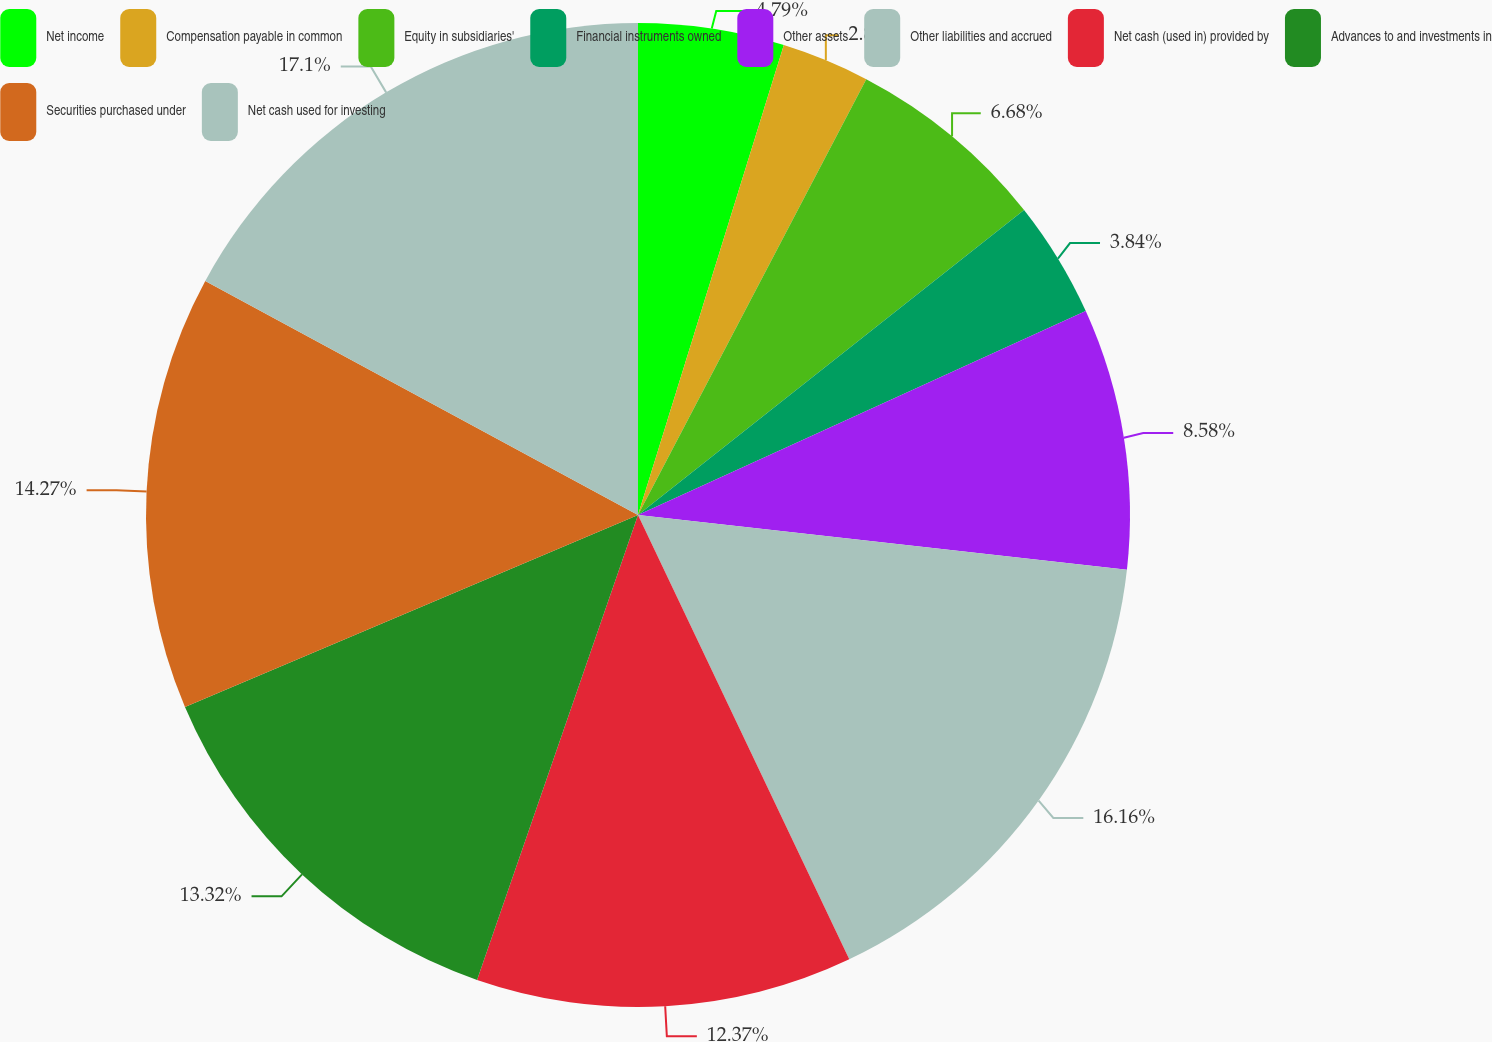<chart> <loc_0><loc_0><loc_500><loc_500><pie_chart><fcel>Net income<fcel>Compensation payable in common<fcel>Equity in subsidiaries'<fcel>Financial instruments owned<fcel>Other assets<fcel>Other liabilities and accrued<fcel>Net cash (used in) provided by<fcel>Advances to and investments in<fcel>Securities purchased under<fcel>Net cash used for investing<nl><fcel>4.79%<fcel>2.89%<fcel>6.68%<fcel>3.84%<fcel>8.58%<fcel>16.16%<fcel>12.37%<fcel>13.32%<fcel>14.27%<fcel>17.11%<nl></chart> 